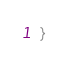Convert code to text. <code><loc_0><loc_0><loc_500><loc_500><_JavaScript_>}</code> 